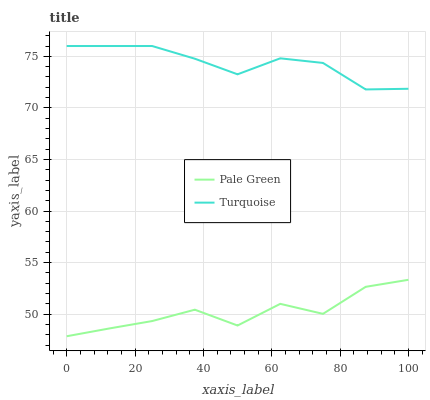Does Pale Green have the maximum area under the curve?
Answer yes or no. No. Is Pale Green the smoothest?
Answer yes or no. No. Does Pale Green have the highest value?
Answer yes or no. No. Is Pale Green less than Turquoise?
Answer yes or no. Yes. Is Turquoise greater than Pale Green?
Answer yes or no. Yes. Does Pale Green intersect Turquoise?
Answer yes or no. No. 